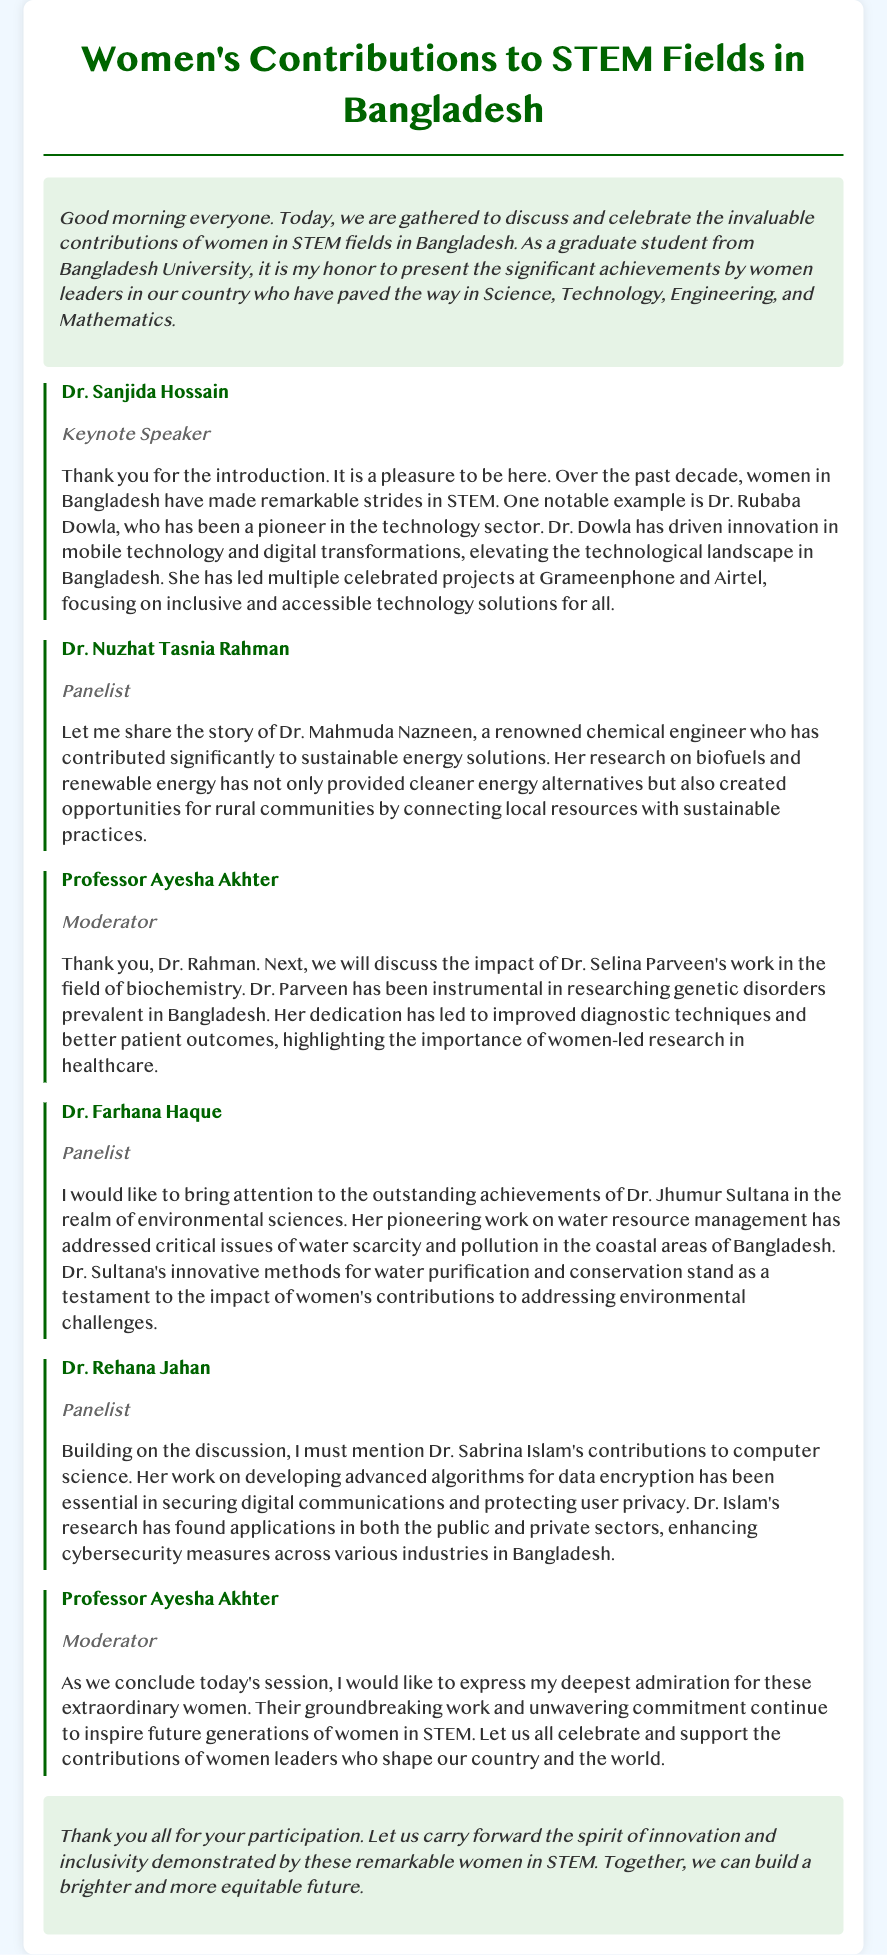What is the name of the keynote speaker? The keynote speaker is the person who delivers the main address at the event, in this case, Dr. Sanjida Hossain.
Answer: Dr. Sanjida Hossain Who is acknowledged for innovation in mobile technology? Dr. Rubaba Dowla is specifically mentioned for her contributions to mobile technology and digital transformations.
Answer: Dr. Rubaba Dowla Which field does Dr. Mahmuda Nazneen specialize in? The document indicates Dr. Mahmuda Nazneen's expertise as a renowned chemical engineer focusing on sustainable energy solutions.
Answer: Chemical engineering What organization is Dr. Dowla associated with for her projects? The document refers to her leadership in projects at Grameenphone and Airtel, highlighting her influence in the technology sector.
Answer: Grameenphone and Airtel Which issue did Dr. Jhumur Sultana address in her work? Her pioneering work is specifically related to water resource management, targeting issues of scarcity and pollution.
Answer: Water scarcity and pollution What is Dr. Sabrina Islam's area of research? The document notes that Dr. Sabrina Islam's contributions relate to data encryption and cybersecurity measures.
Answer: Data encryption and cybersecurity How does Dr. Selina Parveen contribute to healthcare? Dr. Selina Parveen has improved diagnostic techniques for genetic disorders, showcasing the importance of her work in healthcare.
Answer: Genetic disorders What is the primary theme of the event? The event centers around the celebration and discussion of women's contributions in STEM fields in Bangladesh.
Answer: Women's contributions to STEM Who moderated the discussion in the transcript? The moderator is the person overseeing the session, identified in the document as Professor Ayesha Akhter.
Answer: Professor Ayesha Akhter 